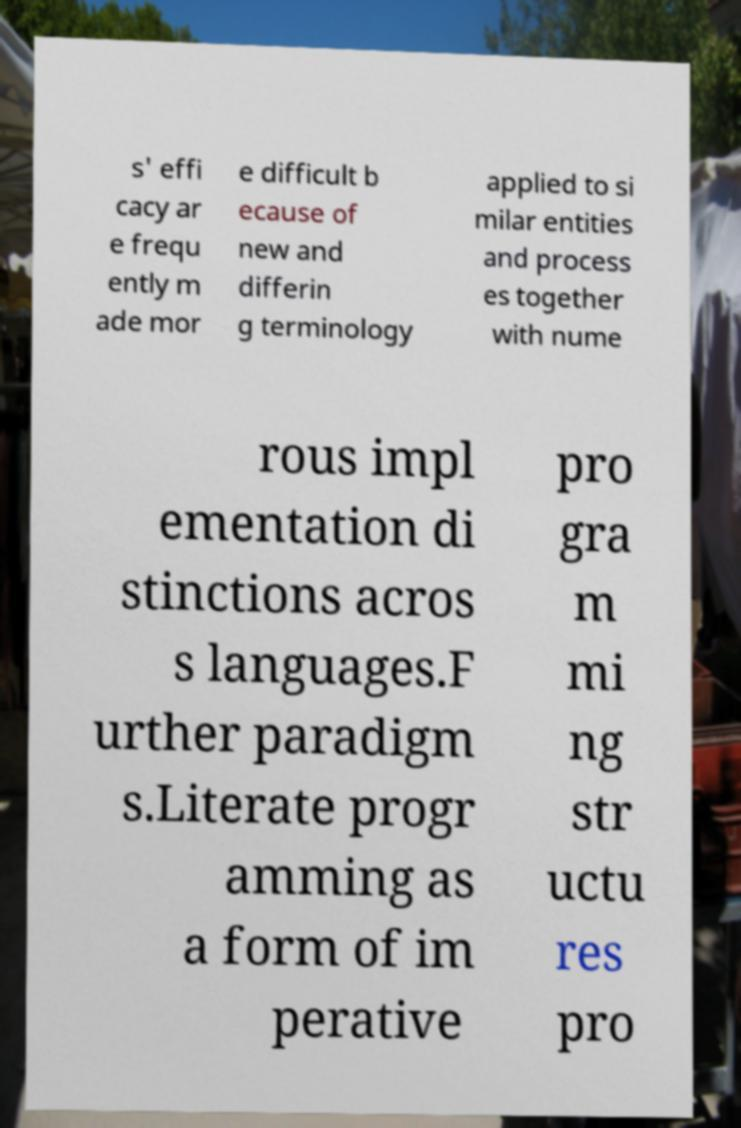I need the written content from this picture converted into text. Can you do that? s' effi cacy ar e frequ ently m ade mor e difficult b ecause of new and differin g terminology applied to si milar entities and process es together with nume rous impl ementation di stinctions acros s languages.F urther paradigm s.Literate progr amming as a form of im perative pro gra m mi ng str uctu res pro 